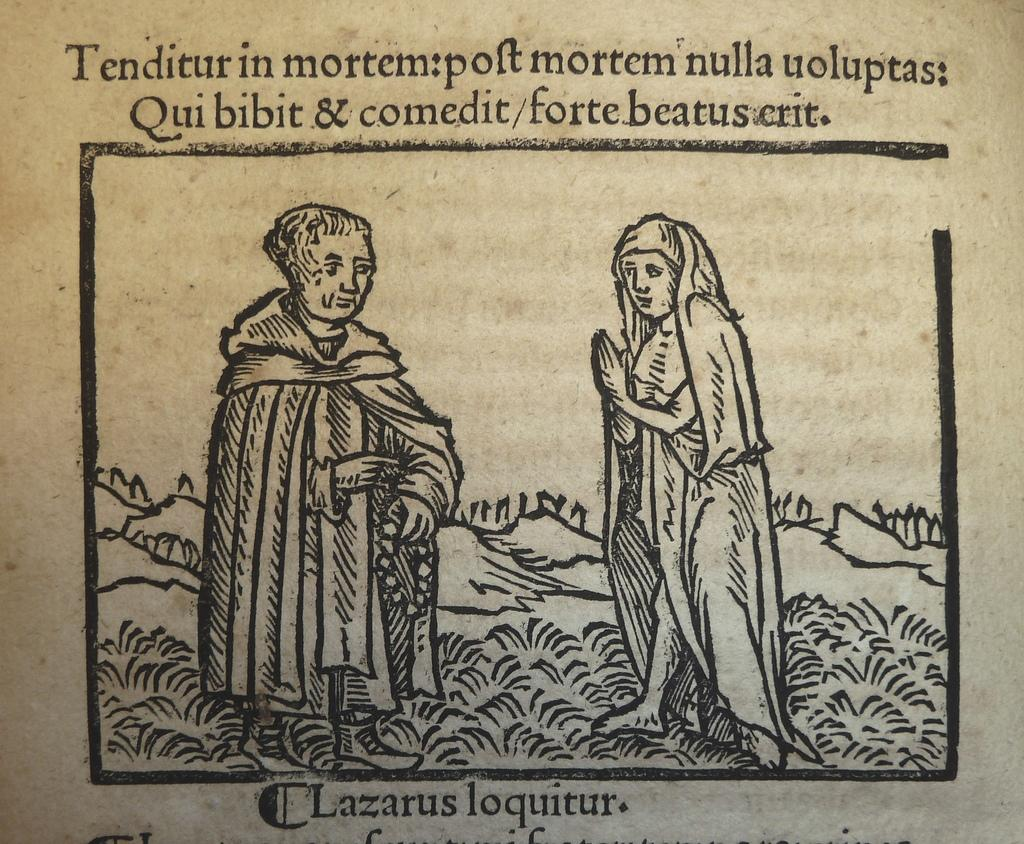What is depicted on the paper in the image? There is a drawing on a paper in the image. What else can be found on the paper in the image? There is text on a paper in the image. How many trucks are shown in the drawing on the paper? There are no trucks depicted in the drawing on the paper; it only contains a drawing and text. What direction is the person sleeping in the image? There is no person sleeping in the image; it only features a drawing and text on a paper. 